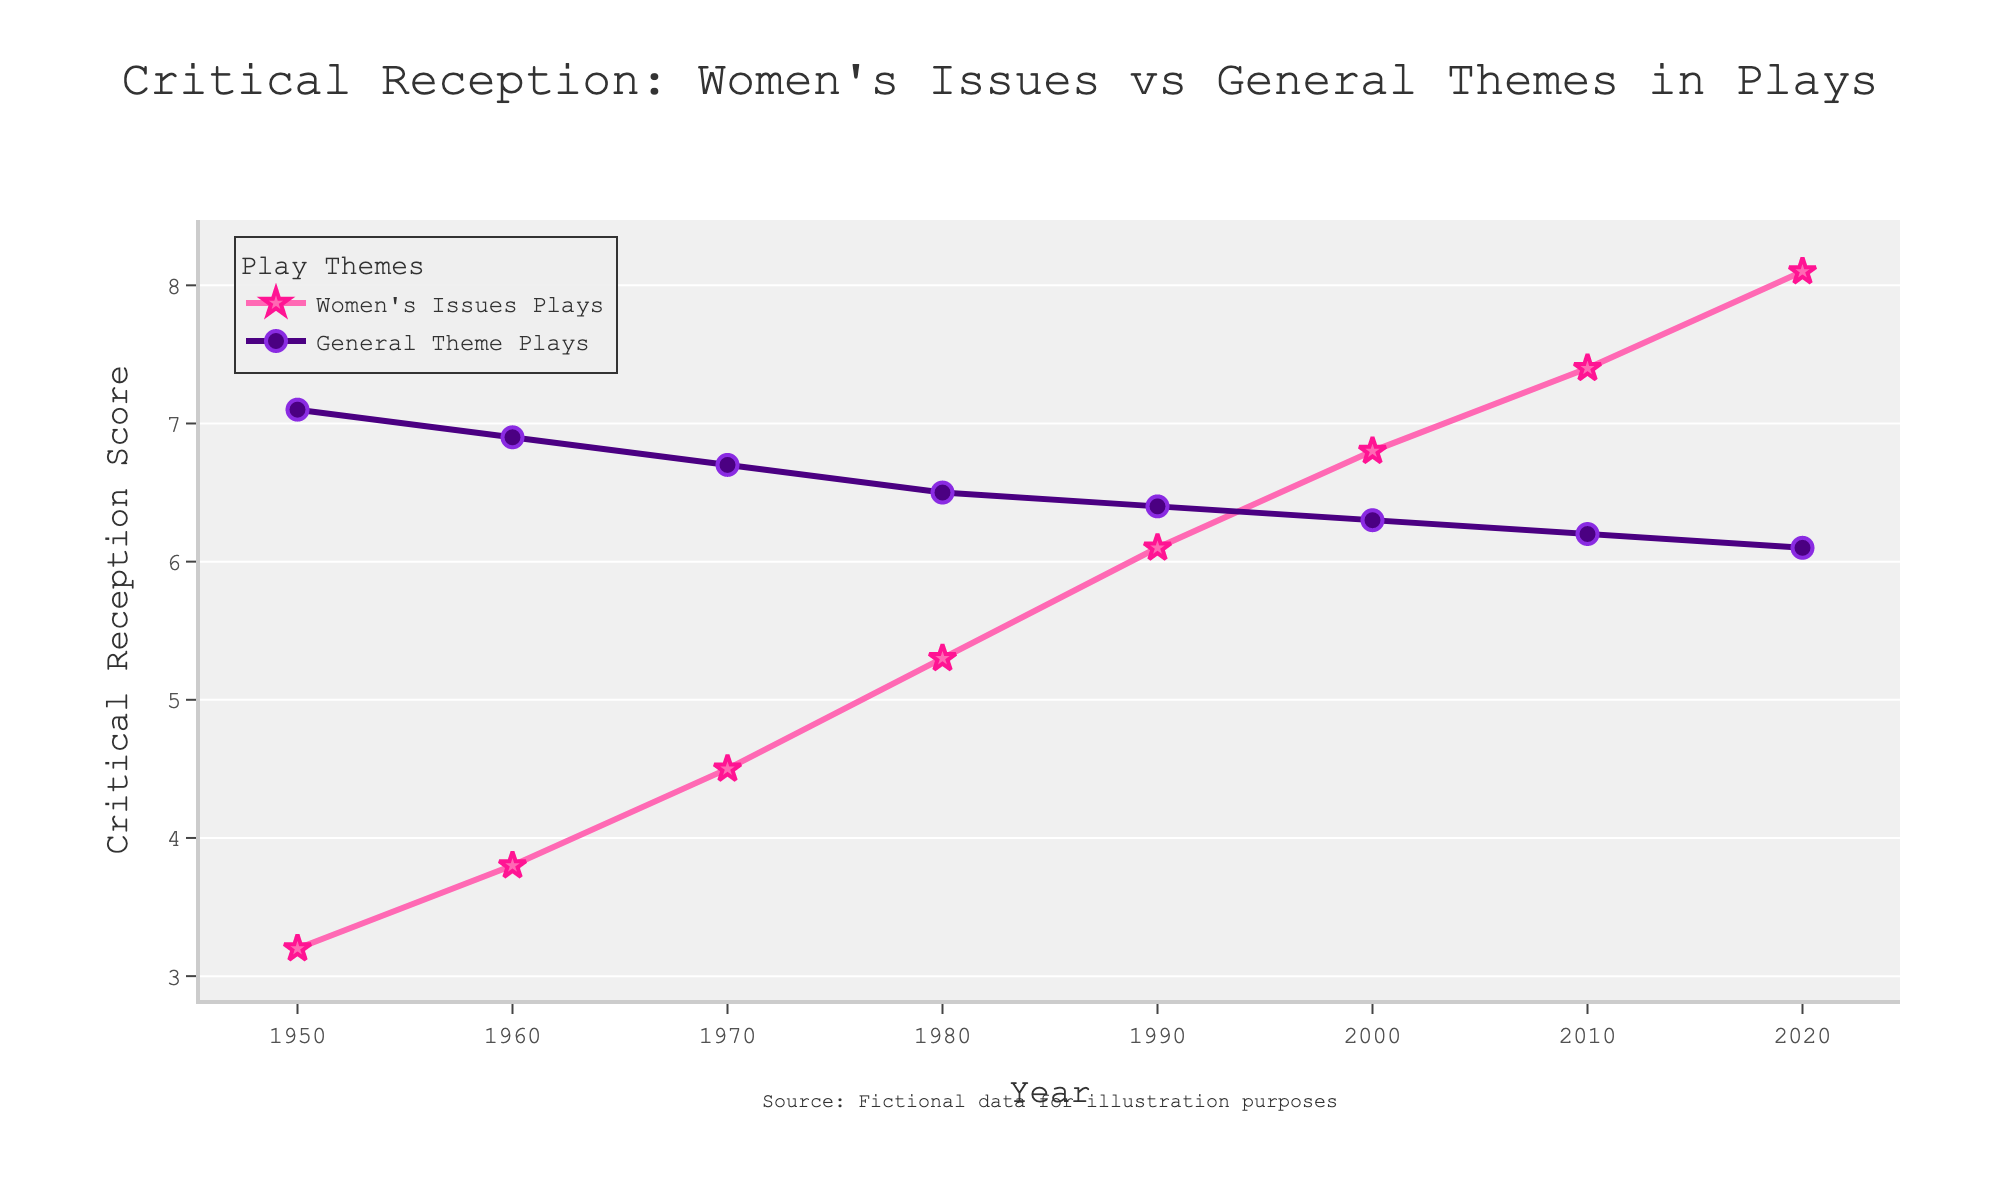What is the trend of critical reception scores for Women's Issues Plays from 1950 to 2020? Observe the pink line representing Women's Issues Plays; it consistently rises from 3.2 in 1950 to 8.1 in 2020, showing a clear upward trend.
Answer: Upward trend How do the critical reception scores of General Theme Plays in 1950 and 2020 compare? Look at the purple line for General Theme Plays; the score is 7.1 in 1950 and 6.1 in 2020, showing a decline over time.
Answer: Decline In which decade did Women's Issues Plays surpass General Theme Plays in critical reception? Check where the pink line starts to go above the purple line. It begins in the 1980s.
Answer: 1980s What is the difference in critical reception scores between Women's Issues Plays and General Theme Plays in 2020? Subtract the score of General Theme Plays (6.1) from that of Women's Issues Plays (8.1). The difference is 2.0.
Answer: 2.0 Which type of play had a more stable critical reception score over the years? Observe the lines; the purple line for General Theme Plays is relatively flat, whereas the pink line for Women's Issues Plays shows significant increases. General Theme Plays have more stable scores.
Answer: General Theme Plays What is the average critical reception score of Women's Issues Plays from 1950 to 2020? Sum all the scores for Women's Issues Plays (3.2, 3.8, 4.5, 5.3, 6.1, 6.8, 7.4, 8.1), which is 45.2. Then divide by 8 (number of years): 45.2/8 = 5.65.
Answer: 5.65 By how much did the critical reception score for Women's Issues Plays increase between 1980 and 2000? Subtract the 1980 score (5.3) from the 2000 score (6.8). The increase is 1.5.
Answer: 1.5 During which decade did the critical reception score for General Theme Plays decline the most? Analyze the plot for the steepest decline in the purple line. It declines the most between 1950 and 1960, from 7.1 to 6.9.
Answer: 1950-1960 Which play type had a higher critical reception score in the year 2010? Compare the scores in 2010; Women's Issues Plays are at 7.4, and General Theme Plays are at 6.2. Women's Issues Plays have a higher score.
Answer: Women's Issues Plays What is the combined critical reception score for both types of plays in the year 1990? Add the scores of Women's Issues Plays (6.1) and General Theme Plays (6.4) for 1990, which sum to 12.5.
Answer: 12.5 